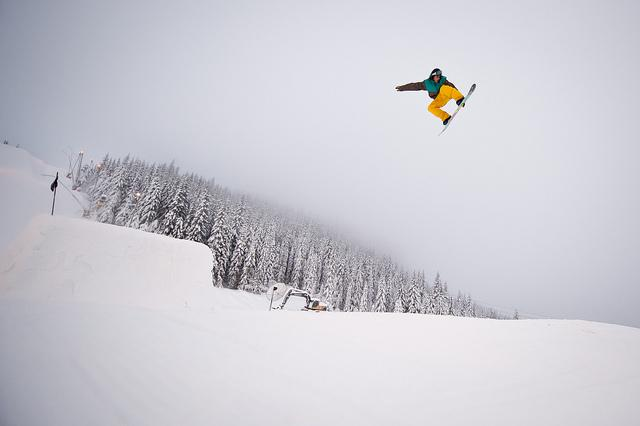How skilled is this skier in the activity? Please explain your reasoning. professional. The person is high up in the air calm and collected without freaking out. 